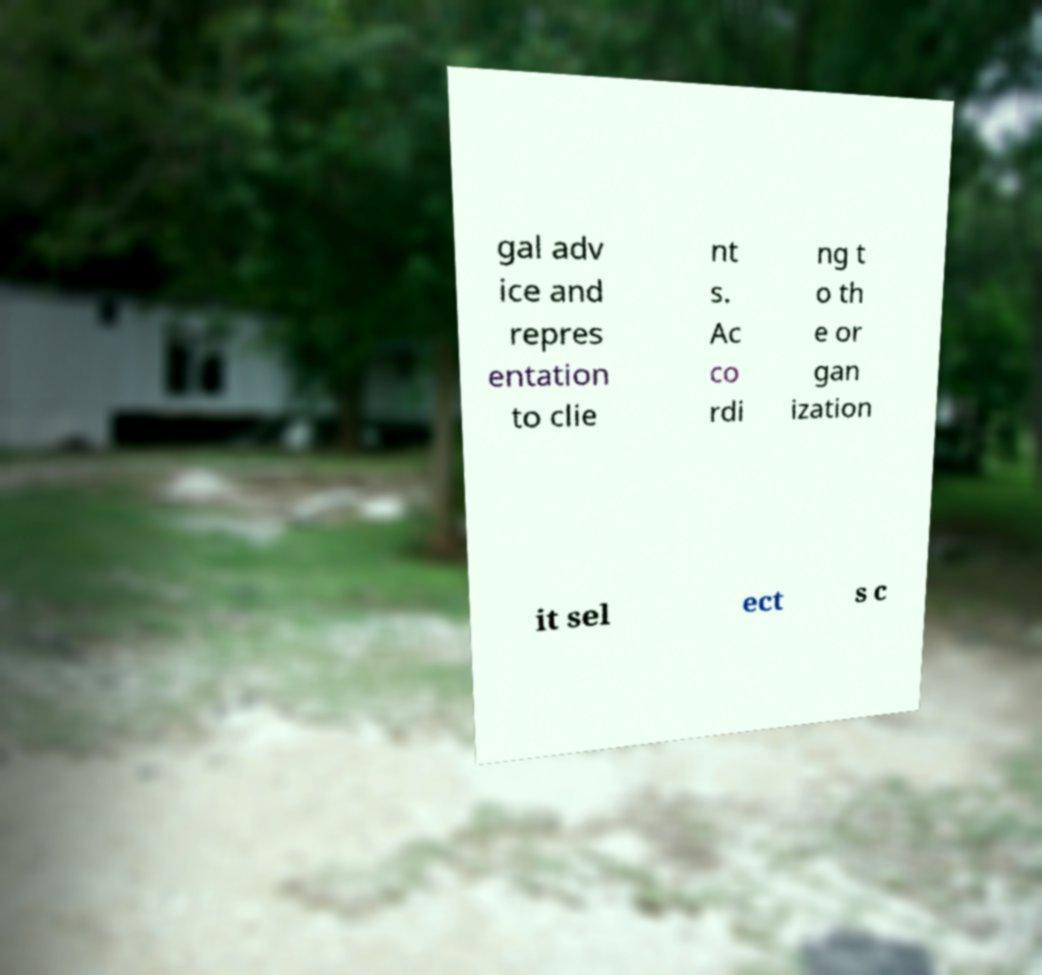There's text embedded in this image that I need extracted. Can you transcribe it verbatim? gal adv ice and repres entation to clie nt s. Ac co rdi ng t o th e or gan ization it sel ect s c 